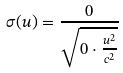<formula> <loc_0><loc_0><loc_500><loc_500>\sigma ( u ) = \frac { 0 } { \sqrt { 0 \cdot \frac { u ^ { 2 } } { c ^ { 2 } } } }</formula> 